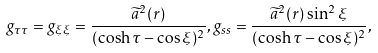<formula> <loc_0><loc_0><loc_500><loc_500>g _ { \tau \tau } = g _ { \xi \xi } = \frac { \widetilde { a } ^ { 2 } ( r ) } { ( \cosh \tau - \cos \xi ) ^ { 2 } } , g _ { s s } = \frac { \widetilde { a } ^ { 2 } ( r ) \sin ^ { 2 } \xi } { ( \cosh \tau - \cos \xi ) ^ { 2 } } ,</formula> 